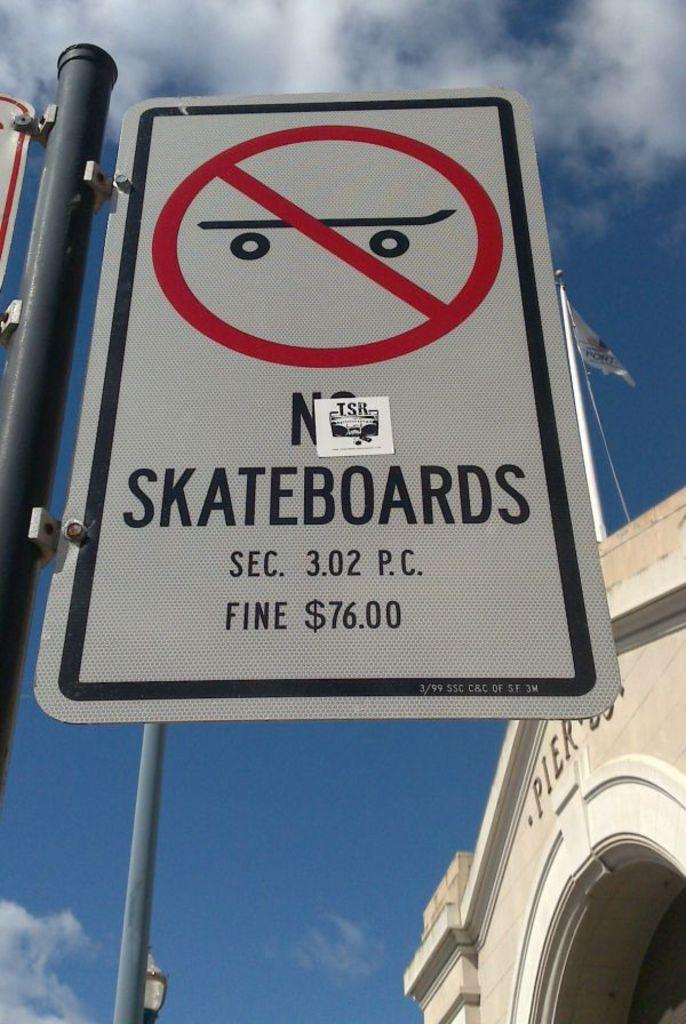What is the main object in the foreground of the image? There is a sign board in the image. What can be seen in the background of the image? There is a building in the background of the image. What other objects are visible in the image? There are poles visible in the image. What part of the natural environment is visible in the image? The sky is visible in the image. Can you see any chess pieces on the sign board in the image? There are no chess pieces visible on the sign board in the image. What type of fang can be seen on the building in the image? There are no fangs present on the building in the image. 